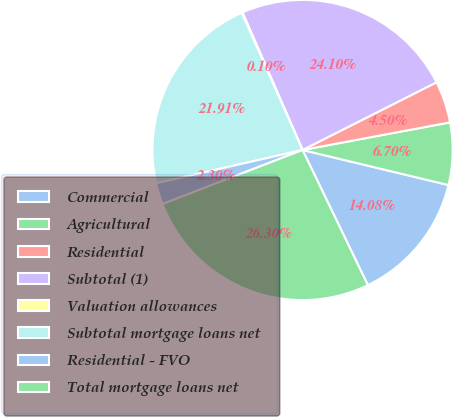Convert chart. <chart><loc_0><loc_0><loc_500><loc_500><pie_chart><fcel>Commercial<fcel>Agricultural<fcel>Residential<fcel>Subtotal (1)<fcel>Valuation allowances<fcel>Subtotal mortgage loans net<fcel>Residential - FVO<fcel>Total mortgage loans net<nl><fcel>14.08%<fcel>6.7%<fcel>4.5%<fcel>24.1%<fcel>0.1%<fcel>21.91%<fcel>2.3%<fcel>26.3%<nl></chart> 